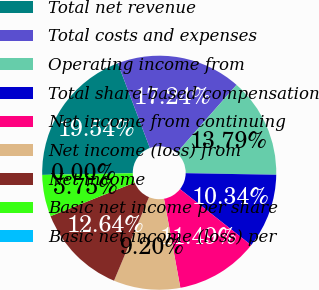<chart> <loc_0><loc_0><loc_500><loc_500><pie_chart><fcel>Total net revenue<fcel>Total costs and expenses<fcel>Operating income from<fcel>Total share-based compensation<fcel>Net income from continuing<fcel>Net income (loss) from<fcel>Net income<fcel>Basic net income per share<fcel>Basic net income (loss) per<nl><fcel>19.54%<fcel>17.24%<fcel>13.79%<fcel>10.34%<fcel>11.49%<fcel>9.2%<fcel>12.64%<fcel>5.75%<fcel>0.0%<nl></chart> 